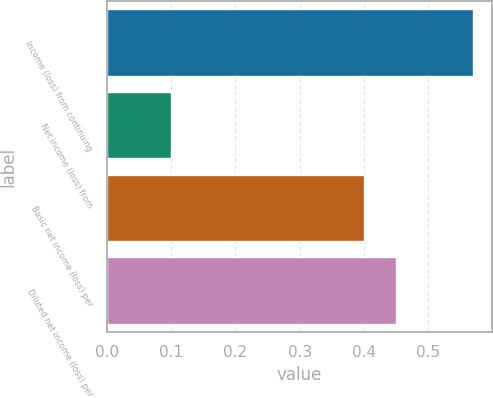<chart> <loc_0><loc_0><loc_500><loc_500><bar_chart><fcel>Income (loss) from continuing<fcel>Net income (loss) from<fcel>Basic net income (loss) per<fcel>Diluted net income (loss) per<nl><fcel>0.57<fcel>0.1<fcel>0.4<fcel>0.45<nl></chart> 